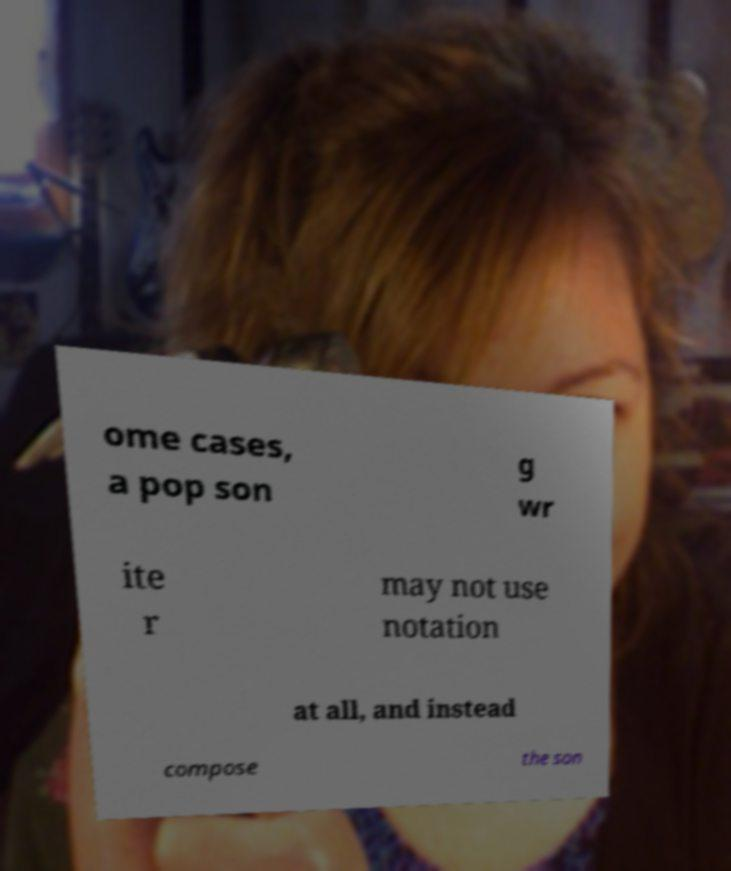Could you extract and type out the text from this image? ome cases, a pop son g wr ite r may not use notation at all, and instead compose the son 